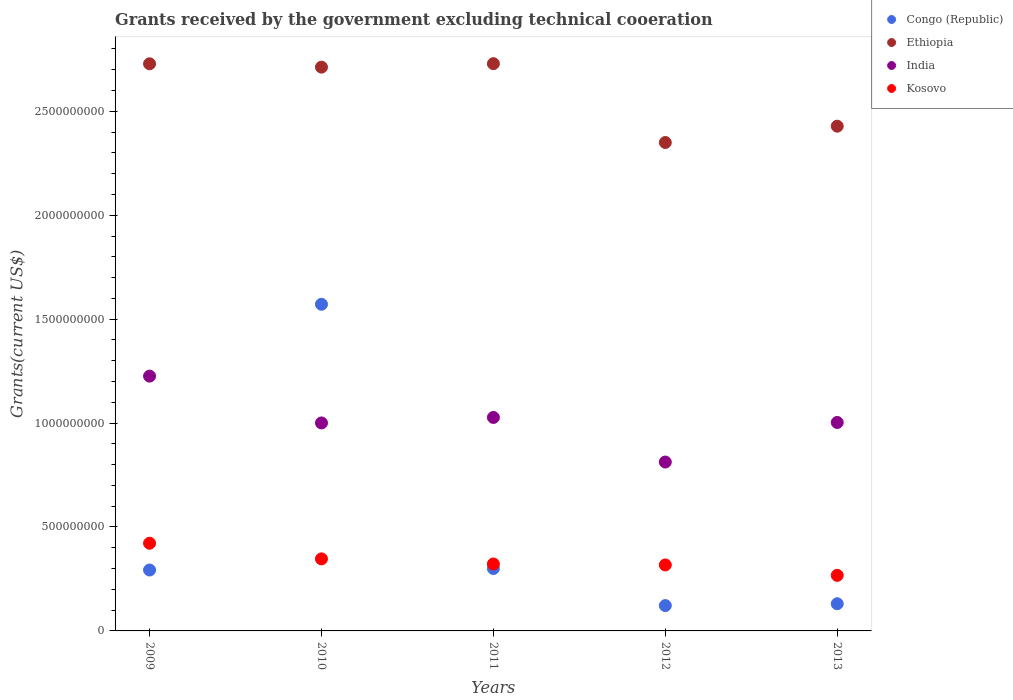Is the number of dotlines equal to the number of legend labels?
Offer a very short reply. Yes. What is the total grants received by the government in Congo (Republic) in 2010?
Ensure brevity in your answer.  1.57e+09. Across all years, what is the maximum total grants received by the government in India?
Your answer should be very brief. 1.23e+09. Across all years, what is the minimum total grants received by the government in Kosovo?
Offer a terse response. 2.67e+08. In which year was the total grants received by the government in Ethiopia maximum?
Give a very brief answer. 2011. In which year was the total grants received by the government in Congo (Republic) minimum?
Offer a very short reply. 2012. What is the total total grants received by the government in Ethiopia in the graph?
Offer a terse response. 1.29e+1. What is the difference between the total grants received by the government in Congo (Republic) in 2010 and that in 2013?
Provide a short and direct response. 1.44e+09. What is the difference between the total grants received by the government in India in 2012 and the total grants received by the government in Ethiopia in 2010?
Provide a succinct answer. -1.90e+09. What is the average total grants received by the government in Kosovo per year?
Offer a very short reply. 3.35e+08. In the year 2009, what is the difference between the total grants received by the government in Ethiopia and total grants received by the government in Kosovo?
Your answer should be very brief. 2.31e+09. What is the ratio of the total grants received by the government in Ethiopia in 2011 to that in 2012?
Offer a very short reply. 1.16. Is the total grants received by the government in Congo (Republic) in 2010 less than that in 2011?
Make the answer very short. No. What is the difference between the highest and the second highest total grants received by the government in Congo (Republic)?
Ensure brevity in your answer.  1.27e+09. What is the difference between the highest and the lowest total grants received by the government in India?
Keep it short and to the point. 4.13e+08. Is it the case that in every year, the sum of the total grants received by the government in India and total grants received by the government in Ethiopia  is greater than the total grants received by the government in Congo (Republic)?
Your answer should be compact. Yes. Does the total grants received by the government in Ethiopia monotonically increase over the years?
Provide a short and direct response. No. Is the total grants received by the government in Kosovo strictly greater than the total grants received by the government in Ethiopia over the years?
Offer a very short reply. No. Is the total grants received by the government in Kosovo strictly less than the total grants received by the government in India over the years?
Your answer should be compact. Yes. How many dotlines are there?
Provide a short and direct response. 4. How many years are there in the graph?
Your answer should be very brief. 5. Are the values on the major ticks of Y-axis written in scientific E-notation?
Make the answer very short. No. Does the graph contain any zero values?
Your response must be concise. No. Does the graph contain grids?
Provide a succinct answer. No. How many legend labels are there?
Offer a very short reply. 4. What is the title of the graph?
Give a very brief answer. Grants received by the government excluding technical cooeration. What is the label or title of the Y-axis?
Provide a succinct answer. Grants(current US$). What is the Grants(current US$) of Congo (Republic) in 2009?
Your answer should be very brief. 2.93e+08. What is the Grants(current US$) in Ethiopia in 2009?
Your response must be concise. 2.73e+09. What is the Grants(current US$) in India in 2009?
Make the answer very short. 1.23e+09. What is the Grants(current US$) in Kosovo in 2009?
Give a very brief answer. 4.22e+08. What is the Grants(current US$) in Congo (Republic) in 2010?
Ensure brevity in your answer.  1.57e+09. What is the Grants(current US$) in Ethiopia in 2010?
Offer a terse response. 2.71e+09. What is the Grants(current US$) in India in 2010?
Your response must be concise. 1.00e+09. What is the Grants(current US$) of Kosovo in 2010?
Provide a succinct answer. 3.47e+08. What is the Grants(current US$) of Congo (Republic) in 2011?
Your answer should be compact. 3.00e+08. What is the Grants(current US$) of Ethiopia in 2011?
Provide a succinct answer. 2.73e+09. What is the Grants(current US$) in India in 2011?
Offer a very short reply. 1.03e+09. What is the Grants(current US$) in Kosovo in 2011?
Provide a succinct answer. 3.22e+08. What is the Grants(current US$) in Congo (Republic) in 2012?
Make the answer very short. 1.22e+08. What is the Grants(current US$) of Ethiopia in 2012?
Give a very brief answer. 2.35e+09. What is the Grants(current US$) of India in 2012?
Give a very brief answer. 8.13e+08. What is the Grants(current US$) of Kosovo in 2012?
Provide a succinct answer. 3.17e+08. What is the Grants(current US$) in Congo (Republic) in 2013?
Make the answer very short. 1.31e+08. What is the Grants(current US$) in Ethiopia in 2013?
Offer a very short reply. 2.43e+09. What is the Grants(current US$) in India in 2013?
Your response must be concise. 1.00e+09. What is the Grants(current US$) of Kosovo in 2013?
Give a very brief answer. 2.67e+08. Across all years, what is the maximum Grants(current US$) in Congo (Republic)?
Your response must be concise. 1.57e+09. Across all years, what is the maximum Grants(current US$) in Ethiopia?
Make the answer very short. 2.73e+09. Across all years, what is the maximum Grants(current US$) of India?
Provide a short and direct response. 1.23e+09. Across all years, what is the maximum Grants(current US$) of Kosovo?
Your answer should be very brief. 4.22e+08. Across all years, what is the minimum Grants(current US$) in Congo (Republic)?
Your answer should be very brief. 1.22e+08. Across all years, what is the minimum Grants(current US$) of Ethiopia?
Keep it short and to the point. 2.35e+09. Across all years, what is the minimum Grants(current US$) in India?
Your answer should be compact. 8.13e+08. Across all years, what is the minimum Grants(current US$) in Kosovo?
Keep it short and to the point. 2.67e+08. What is the total Grants(current US$) in Congo (Republic) in the graph?
Keep it short and to the point. 2.42e+09. What is the total Grants(current US$) of Ethiopia in the graph?
Offer a terse response. 1.29e+1. What is the total Grants(current US$) in India in the graph?
Offer a terse response. 5.07e+09. What is the total Grants(current US$) in Kosovo in the graph?
Offer a terse response. 1.68e+09. What is the difference between the Grants(current US$) of Congo (Republic) in 2009 and that in 2010?
Your answer should be very brief. -1.28e+09. What is the difference between the Grants(current US$) in Ethiopia in 2009 and that in 2010?
Offer a terse response. 1.60e+07. What is the difference between the Grants(current US$) of India in 2009 and that in 2010?
Your answer should be compact. 2.25e+08. What is the difference between the Grants(current US$) in Kosovo in 2009 and that in 2010?
Offer a terse response. 7.53e+07. What is the difference between the Grants(current US$) of Congo (Republic) in 2009 and that in 2011?
Keep it short and to the point. -7.13e+06. What is the difference between the Grants(current US$) in Ethiopia in 2009 and that in 2011?
Your answer should be very brief. -6.20e+05. What is the difference between the Grants(current US$) of India in 2009 and that in 2011?
Ensure brevity in your answer.  1.99e+08. What is the difference between the Grants(current US$) in Kosovo in 2009 and that in 2011?
Your response must be concise. 9.97e+07. What is the difference between the Grants(current US$) in Congo (Republic) in 2009 and that in 2012?
Make the answer very short. 1.71e+08. What is the difference between the Grants(current US$) of Ethiopia in 2009 and that in 2012?
Make the answer very short. 3.79e+08. What is the difference between the Grants(current US$) of India in 2009 and that in 2012?
Offer a terse response. 4.13e+08. What is the difference between the Grants(current US$) of Kosovo in 2009 and that in 2012?
Keep it short and to the point. 1.04e+08. What is the difference between the Grants(current US$) in Congo (Republic) in 2009 and that in 2013?
Keep it short and to the point. 1.62e+08. What is the difference between the Grants(current US$) in Ethiopia in 2009 and that in 2013?
Give a very brief answer. 3.00e+08. What is the difference between the Grants(current US$) of India in 2009 and that in 2013?
Provide a short and direct response. 2.23e+08. What is the difference between the Grants(current US$) of Kosovo in 2009 and that in 2013?
Offer a very short reply. 1.55e+08. What is the difference between the Grants(current US$) in Congo (Republic) in 2010 and that in 2011?
Give a very brief answer. 1.27e+09. What is the difference between the Grants(current US$) in Ethiopia in 2010 and that in 2011?
Offer a terse response. -1.66e+07. What is the difference between the Grants(current US$) in India in 2010 and that in 2011?
Your response must be concise. -2.64e+07. What is the difference between the Grants(current US$) of Kosovo in 2010 and that in 2011?
Keep it short and to the point. 2.44e+07. What is the difference between the Grants(current US$) of Congo (Republic) in 2010 and that in 2012?
Your answer should be compact. 1.45e+09. What is the difference between the Grants(current US$) in Ethiopia in 2010 and that in 2012?
Your answer should be very brief. 3.63e+08. What is the difference between the Grants(current US$) in India in 2010 and that in 2012?
Offer a very short reply. 1.88e+08. What is the difference between the Grants(current US$) of Kosovo in 2010 and that in 2012?
Your answer should be very brief. 2.92e+07. What is the difference between the Grants(current US$) of Congo (Republic) in 2010 and that in 2013?
Ensure brevity in your answer.  1.44e+09. What is the difference between the Grants(current US$) of Ethiopia in 2010 and that in 2013?
Ensure brevity in your answer.  2.84e+08. What is the difference between the Grants(current US$) of India in 2010 and that in 2013?
Your answer should be compact. -2.22e+06. What is the difference between the Grants(current US$) in Kosovo in 2010 and that in 2013?
Provide a short and direct response. 7.93e+07. What is the difference between the Grants(current US$) in Congo (Republic) in 2011 and that in 2012?
Offer a very short reply. 1.78e+08. What is the difference between the Grants(current US$) of Ethiopia in 2011 and that in 2012?
Your answer should be very brief. 3.79e+08. What is the difference between the Grants(current US$) in India in 2011 and that in 2012?
Your answer should be very brief. 2.14e+08. What is the difference between the Grants(current US$) in Kosovo in 2011 and that in 2012?
Your response must be concise. 4.73e+06. What is the difference between the Grants(current US$) in Congo (Republic) in 2011 and that in 2013?
Keep it short and to the point. 1.69e+08. What is the difference between the Grants(current US$) of Ethiopia in 2011 and that in 2013?
Your answer should be compact. 3.01e+08. What is the difference between the Grants(current US$) in India in 2011 and that in 2013?
Your answer should be very brief. 2.42e+07. What is the difference between the Grants(current US$) of Kosovo in 2011 and that in 2013?
Make the answer very short. 5.48e+07. What is the difference between the Grants(current US$) in Congo (Republic) in 2012 and that in 2013?
Your answer should be very brief. -8.87e+06. What is the difference between the Grants(current US$) of Ethiopia in 2012 and that in 2013?
Give a very brief answer. -7.86e+07. What is the difference between the Grants(current US$) in India in 2012 and that in 2013?
Make the answer very short. -1.90e+08. What is the difference between the Grants(current US$) of Kosovo in 2012 and that in 2013?
Provide a short and direct response. 5.01e+07. What is the difference between the Grants(current US$) in Congo (Republic) in 2009 and the Grants(current US$) in Ethiopia in 2010?
Keep it short and to the point. -2.42e+09. What is the difference between the Grants(current US$) in Congo (Republic) in 2009 and the Grants(current US$) in India in 2010?
Your answer should be compact. -7.08e+08. What is the difference between the Grants(current US$) of Congo (Republic) in 2009 and the Grants(current US$) of Kosovo in 2010?
Provide a short and direct response. -5.36e+07. What is the difference between the Grants(current US$) in Ethiopia in 2009 and the Grants(current US$) in India in 2010?
Keep it short and to the point. 1.73e+09. What is the difference between the Grants(current US$) of Ethiopia in 2009 and the Grants(current US$) of Kosovo in 2010?
Provide a short and direct response. 2.38e+09. What is the difference between the Grants(current US$) of India in 2009 and the Grants(current US$) of Kosovo in 2010?
Your response must be concise. 8.79e+08. What is the difference between the Grants(current US$) in Congo (Republic) in 2009 and the Grants(current US$) in Ethiopia in 2011?
Make the answer very short. -2.44e+09. What is the difference between the Grants(current US$) of Congo (Republic) in 2009 and the Grants(current US$) of India in 2011?
Provide a short and direct response. -7.34e+08. What is the difference between the Grants(current US$) in Congo (Republic) in 2009 and the Grants(current US$) in Kosovo in 2011?
Make the answer very short. -2.91e+07. What is the difference between the Grants(current US$) of Ethiopia in 2009 and the Grants(current US$) of India in 2011?
Your answer should be very brief. 1.70e+09. What is the difference between the Grants(current US$) of Ethiopia in 2009 and the Grants(current US$) of Kosovo in 2011?
Give a very brief answer. 2.41e+09. What is the difference between the Grants(current US$) of India in 2009 and the Grants(current US$) of Kosovo in 2011?
Offer a terse response. 9.04e+08. What is the difference between the Grants(current US$) of Congo (Republic) in 2009 and the Grants(current US$) of Ethiopia in 2012?
Keep it short and to the point. -2.06e+09. What is the difference between the Grants(current US$) of Congo (Republic) in 2009 and the Grants(current US$) of India in 2012?
Your answer should be very brief. -5.20e+08. What is the difference between the Grants(current US$) of Congo (Republic) in 2009 and the Grants(current US$) of Kosovo in 2012?
Your answer should be compact. -2.44e+07. What is the difference between the Grants(current US$) in Ethiopia in 2009 and the Grants(current US$) in India in 2012?
Ensure brevity in your answer.  1.92e+09. What is the difference between the Grants(current US$) in Ethiopia in 2009 and the Grants(current US$) in Kosovo in 2012?
Provide a short and direct response. 2.41e+09. What is the difference between the Grants(current US$) in India in 2009 and the Grants(current US$) in Kosovo in 2012?
Your answer should be very brief. 9.08e+08. What is the difference between the Grants(current US$) in Congo (Republic) in 2009 and the Grants(current US$) in Ethiopia in 2013?
Your response must be concise. -2.14e+09. What is the difference between the Grants(current US$) of Congo (Republic) in 2009 and the Grants(current US$) of India in 2013?
Offer a very short reply. -7.10e+08. What is the difference between the Grants(current US$) in Congo (Republic) in 2009 and the Grants(current US$) in Kosovo in 2013?
Your answer should be very brief. 2.57e+07. What is the difference between the Grants(current US$) of Ethiopia in 2009 and the Grants(current US$) of India in 2013?
Ensure brevity in your answer.  1.73e+09. What is the difference between the Grants(current US$) in Ethiopia in 2009 and the Grants(current US$) in Kosovo in 2013?
Make the answer very short. 2.46e+09. What is the difference between the Grants(current US$) in India in 2009 and the Grants(current US$) in Kosovo in 2013?
Provide a short and direct response. 9.59e+08. What is the difference between the Grants(current US$) of Congo (Republic) in 2010 and the Grants(current US$) of Ethiopia in 2011?
Ensure brevity in your answer.  -1.16e+09. What is the difference between the Grants(current US$) of Congo (Republic) in 2010 and the Grants(current US$) of India in 2011?
Offer a terse response. 5.45e+08. What is the difference between the Grants(current US$) in Congo (Republic) in 2010 and the Grants(current US$) in Kosovo in 2011?
Provide a short and direct response. 1.25e+09. What is the difference between the Grants(current US$) in Ethiopia in 2010 and the Grants(current US$) in India in 2011?
Your answer should be compact. 1.69e+09. What is the difference between the Grants(current US$) in Ethiopia in 2010 and the Grants(current US$) in Kosovo in 2011?
Your answer should be very brief. 2.39e+09. What is the difference between the Grants(current US$) of India in 2010 and the Grants(current US$) of Kosovo in 2011?
Give a very brief answer. 6.78e+08. What is the difference between the Grants(current US$) in Congo (Republic) in 2010 and the Grants(current US$) in Ethiopia in 2012?
Give a very brief answer. -7.78e+08. What is the difference between the Grants(current US$) in Congo (Republic) in 2010 and the Grants(current US$) in India in 2012?
Keep it short and to the point. 7.59e+08. What is the difference between the Grants(current US$) in Congo (Republic) in 2010 and the Grants(current US$) in Kosovo in 2012?
Your answer should be compact. 1.25e+09. What is the difference between the Grants(current US$) of Ethiopia in 2010 and the Grants(current US$) of India in 2012?
Offer a very short reply. 1.90e+09. What is the difference between the Grants(current US$) in Ethiopia in 2010 and the Grants(current US$) in Kosovo in 2012?
Offer a very short reply. 2.40e+09. What is the difference between the Grants(current US$) of India in 2010 and the Grants(current US$) of Kosovo in 2012?
Give a very brief answer. 6.83e+08. What is the difference between the Grants(current US$) in Congo (Republic) in 2010 and the Grants(current US$) in Ethiopia in 2013?
Ensure brevity in your answer.  -8.57e+08. What is the difference between the Grants(current US$) in Congo (Republic) in 2010 and the Grants(current US$) in India in 2013?
Offer a terse response. 5.69e+08. What is the difference between the Grants(current US$) in Congo (Republic) in 2010 and the Grants(current US$) in Kosovo in 2013?
Keep it short and to the point. 1.30e+09. What is the difference between the Grants(current US$) of Ethiopia in 2010 and the Grants(current US$) of India in 2013?
Offer a terse response. 1.71e+09. What is the difference between the Grants(current US$) of Ethiopia in 2010 and the Grants(current US$) of Kosovo in 2013?
Your answer should be very brief. 2.45e+09. What is the difference between the Grants(current US$) of India in 2010 and the Grants(current US$) of Kosovo in 2013?
Offer a terse response. 7.33e+08. What is the difference between the Grants(current US$) of Congo (Republic) in 2011 and the Grants(current US$) of Ethiopia in 2012?
Your answer should be very brief. -2.05e+09. What is the difference between the Grants(current US$) of Congo (Republic) in 2011 and the Grants(current US$) of India in 2012?
Offer a very short reply. -5.12e+08. What is the difference between the Grants(current US$) in Congo (Republic) in 2011 and the Grants(current US$) in Kosovo in 2012?
Make the answer very short. -1.73e+07. What is the difference between the Grants(current US$) of Ethiopia in 2011 and the Grants(current US$) of India in 2012?
Make the answer very short. 1.92e+09. What is the difference between the Grants(current US$) in Ethiopia in 2011 and the Grants(current US$) in Kosovo in 2012?
Offer a terse response. 2.41e+09. What is the difference between the Grants(current US$) in India in 2011 and the Grants(current US$) in Kosovo in 2012?
Provide a succinct answer. 7.10e+08. What is the difference between the Grants(current US$) of Congo (Republic) in 2011 and the Grants(current US$) of Ethiopia in 2013?
Give a very brief answer. -2.13e+09. What is the difference between the Grants(current US$) in Congo (Republic) in 2011 and the Grants(current US$) in India in 2013?
Make the answer very short. -7.03e+08. What is the difference between the Grants(current US$) in Congo (Republic) in 2011 and the Grants(current US$) in Kosovo in 2013?
Your answer should be compact. 3.28e+07. What is the difference between the Grants(current US$) in Ethiopia in 2011 and the Grants(current US$) in India in 2013?
Ensure brevity in your answer.  1.73e+09. What is the difference between the Grants(current US$) in Ethiopia in 2011 and the Grants(current US$) in Kosovo in 2013?
Give a very brief answer. 2.46e+09. What is the difference between the Grants(current US$) in India in 2011 and the Grants(current US$) in Kosovo in 2013?
Your response must be concise. 7.60e+08. What is the difference between the Grants(current US$) in Congo (Republic) in 2012 and the Grants(current US$) in Ethiopia in 2013?
Your answer should be compact. -2.31e+09. What is the difference between the Grants(current US$) of Congo (Republic) in 2012 and the Grants(current US$) of India in 2013?
Provide a short and direct response. -8.81e+08. What is the difference between the Grants(current US$) in Congo (Republic) in 2012 and the Grants(current US$) in Kosovo in 2013?
Provide a short and direct response. -1.45e+08. What is the difference between the Grants(current US$) of Ethiopia in 2012 and the Grants(current US$) of India in 2013?
Ensure brevity in your answer.  1.35e+09. What is the difference between the Grants(current US$) in Ethiopia in 2012 and the Grants(current US$) in Kosovo in 2013?
Keep it short and to the point. 2.08e+09. What is the difference between the Grants(current US$) of India in 2012 and the Grants(current US$) of Kosovo in 2013?
Provide a short and direct response. 5.45e+08. What is the average Grants(current US$) of Congo (Republic) per year?
Offer a very short reply. 4.83e+08. What is the average Grants(current US$) of Ethiopia per year?
Provide a succinct answer. 2.59e+09. What is the average Grants(current US$) of India per year?
Give a very brief answer. 1.01e+09. What is the average Grants(current US$) in Kosovo per year?
Make the answer very short. 3.35e+08. In the year 2009, what is the difference between the Grants(current US$) in Congo (Republic) and Grants(current US$) in Ethiopia?
Your answer should be very brief. -2.44e+09. In the year 2009, what is the difference between the Grants(current US$) of Congo (Republic) and Grants(current US$) of India?
Keep it short and to the point. -9.33e+08. In the year 2009, what is the difference between the Grants(current US$) in Congo (Republic) and Grants(current US$) in Kosovo?
Offer a terse response. -1.29e+08. In the year 2009, what is the difference between the Grants(current US$) in Ethiopia and Grants(current US$) in India?
Make the answer very short. 1.50e+09. In the year 2009, what is the difference between the Grants(current US$) in Ethiopia and Grants(current US$) in Kosovo?
Offer a very short reply. 2.31e+09. In the year 2009, what is the difference between the Grants(current US$) of India and Grants(current US$) of Kosovo?
Make the answer very short. 8.04e+08. In the year 2010, what is the difference between the Grants(current US$) in Congo (Republic) and Grants(current US$) in Ethiopia?
Give a very brief answer. -1.14e+09. In the year 2010, what is the difference between the Grants(current US$) in Congo (Republic) and Grants(current US$) in India?
Offer a very short reply. 5.71e+08. In the year 2010, what is the difference between the Grants(current US$) of Congo (Republic) and Grants(current US$) of Kosovo?
Ensure brevity in your answer.  1.22e+09. In the year 2010, what is the difference between the Grants(current US$) in Ethiopia and Grants(current US$) in India?
Provide a short and direct response. 1.71e+09. In the year 2010, what is the difference between the Grants(current US$) of Ethiopia and Grants(current US$) of Kosovo?
Give a very brief answer. 2.37e+09. In the year 2010, what is the difference between the Grants(current US$) of India and Grants(current US$) of Kosovo?
Give a very brief answer. 6.54e+08. In the year 2011, what is the difference between the Grants(current US$) in Congo (Republic) and Grants(current US$) in Ethiopia?
Ensure brevity in your answer.  -2.43e+09. In the year 2011, what is the difference between the Grants(current US$) of Congo (Republic) and Grants(current US$) of India?
Give a very brief answer. -7.27e+08. In the year 2011, what is the difference between the Grants(current US$) in Congo (Republic) and Grants(current US$) in Kosovo?
Provide a succinct answer. -2.20e+07. In the year 2011, what is the difference between the Grants(current US$) in Ethiopia and Grants(current US$) in India?
Offer a terse response. 1.70e+09. In the year 2011, what is the difference between the Grants(current US$) in Ethiopia and Grants(current US$) in Kosovo?
Offer a very short reply. 2.41e+09. In the year 2011, what is the difference between the Grants(current US$) of India and Grants(current US$) of Kosovo?
Your answer should be very brief. 7.05e+08. In the year 2012, what is the difference between the Grants(current US$) in Congo (Republic) and Grants(current US$) in Ethiopia?
Give a very brief answer. -2.23e+09. In the year 2012, what is the difference between the Grants(current US$) of Congo (Republic) and Grants(current US$) of India?
Provide a succinct answer. -6.91e+08. In the year 2012, what is the difference between the Grants(current US$) in Congo (Republic) and Grants(current US$) in Kosovo?
Give a very brief answer. -1.96e+08. In the year 2012, what is the difference between the Grants(current US$) of Ethiopia and Grants(current US$) of India?
Your response must be concise. 1.54e+09. In the year 2012, what is the difference between the Grants(current US$) of Ethiopia and Grants(current US$) of Kosovo?
Your answer should be compact. 2.03e+09. In the year 2012, what is the difference between the Grants(current US$) in India and Grants(current US$) in Kosovo?
Offer a very short reply. 4.95e+08. In the year 2013, what is the difference between the Grants(current US$) in Congo (Republic) and Grants(current US$) in Ethiopia?
Your response must be concise. -2.30e+09. In the year 2013, what is the difference between the Grants(current US$) of Congo (Republic) and Grants(current US$) of India?
Make the answer very short. -8.72e+08. In the year 2013, what is the difference between the Grants(current US$) of Congo (Republic) and Grants(current US$) of Kosovo?
Ensure brevity in your answer.  -1.37e+08. In the year 2013, what is the difference between the Grants(current US$) in Ethiopia and Grants(current US$) in India?
Your answer should be very brief. 1.43e+09. In the year 2013, what is the difference between the Grants(current US$) of Ethiopia and Grants(current US$) of Kosovo?
Your answer should be compact. 2.16e+09. In the year 2013, what is the difference between the Grants(current US$) of India and Grants(current US$) of Kosovo?
Provide a short and direct response. 7.36e+08. What is the ratio of the Grants(current US$) in Congo (Republic) in 2009 to that in 2010?
Make the answer very short. 0.19. What is the ratio of the Grants(current US$) of Ethiopia in 2009 to that in 2010?
Keep it short and to the point. 1.01. What is the ratio of the Grants(current US$) in India in 2009 to that in 2010?
Give a very brief answer. 1.23. What is the ratio of the Grants(current US$) of Kosovo in 2009 to that in 2010?
Offer a very short reply. 1.22. What is the ratio of the Grants(current US$) in Congo (Republic) in 2009 to that in 2011?
Ensure brevity in your answer.  0.98. What is the ratio of the Grants(current US$) of India in 2009 to that in 2011?
Provide a succinct answer. 1.19. What is the ratio of the Grants(current US$) of Kosovo in 2009 to that in 2011?
Make the answer very short. 1.31. What is the ratio of the Grants(current US$) in Congo (Republic) in 2009 to that in 2012?
Offer a very short reply. 2.4. What is the ratio of the Grants(current US$) in Ethiopia in 2009 to that in 2012?
Offer a terse response. 1.16. What is the ratio of the Grants(current US$) of India in 2009 to that in 2012?
Keep it short and to the point. 1.51. What is the ratio of the Grants(current US$) of Kosovo in 2009 to that in 2012?
Provide a short and direct response. 1.33. What is the ratio of the Grants(current US$) in Congo (Republic) in 2009 to that in 2013?
Your response must be concise. 2.24. What is the ratio of the Grants(current US$) in Ethiopia in 2009 to that in 2013?
Ensure brevity in your answer.  1.12. What is the ratio of the Grants(current US$) of India in 2009 to that in 2013?
Provide a succinct answer. 1.22. What is the ratio of the Grants(current US$) of Kosovo in 2009 to that in 2013?
Your response must be concise. 1.58. What is the ratio of the Grants(current US$) of Congo (Republic) in 2010 to that in 2011?
Keep it short and to the point. 5.24. What is the ratio of the Grants(current US$) in Ethiopia in 2010 to that in 2011?
Make the answer very short. 0.99. What is the ratio of the Grants(current US$) of India in 2010 to that in 2011?
Keep it short and to the point. 0.97. What is the ratio of the Grants(current US$) of Kosovo in 2010 to that in 2011?
Provide a succinct answer. 1.08. What is the ratio of the Grants(current US$) in Congo (Republic) in 2010 to that in 2012?
Keep it short and to the point. 12.89. What is the ratio of the Grants(current US$) of Ethiopia in 2010 to that in 2012?
Make the answer very short. 1.15. What is the ratio of the Grants(current US$) of India in 2010 to that in 2012?
Ensure brevity in your answer.  1.23. What is the ratio of the Grants(current US$) of Kosovo in 2010 to that in 2012?
Keep it short and to the point. 1.09. What is the ratio of the Grants(current US$) in Congo (Republic) in 2010 to that in 2013?
Keep it short and to the point. 12.02. What is the ratio of the Grants(current US$) of Ethiopia in 2010 to that in 2013?
Your answer should be very brief. 1.12. What is the ratio of the Grants(current US$) of India in 2010 to that in 2013?
Your answer should be very brief. 1. What is the ratio of the Grants(current US$) in Kosovo in 2010 to that in 2013?
Keep it short and to the point. 1.3. What is the ratio of the Grants(current US$) of Congo (Republic) in 2011 to that in 2012?
Give a very brief answer. 2.46. What is the ratio of the Grants(current US$) in Ethiopia in 2011 to that in 2012?
Keep it short and to the point. 1.16. What is the ratio of the Grants(current US$) of India in 2011 to that in 2012?
Offer a terse response. 1.26. What is the ratio of the Grants(current US$) in Kosovo in 2011 to that in 2012?
Your response must be concise. 1.01. What is the ratio of the Grants(current US$) in Congo (Republic) in 2011 to that in 2013?
Provide a succinct answer. 2.3. What is the ratio of the Grants(current US$) in Ethiopia in 2011 to that in 2013?
Offer a terse response. 1.12. What is the ratio of the Grants(current US$) in India in 2011 to that in 2013?
Provide a succinct answer. 1.02. What is the ratio of the Grants(current US$) of Kosovo in 2011 to that in 2013?
Make the answer very short. 1.21. What is the ratio of the Grants(current US$) in Congo (Republic) in 2012 to that in 2013?
Your answer should be compact. 0.93. What is the ratio of the Grants(current US$) in Ethiopia in 2012 to that in 2013?
Keep it short and to the point. 0.97. What is the ratio of the Grants(current US$) in India in 2012 to that in 2013?
Give a very brief answer. 0.81. What is the ratio of the Grants(current US$) in Kosovo in 2012 to that in 2013?
Offer a very short reply. 1.19. What is the difference between the highest and the second highest Grants(current US$) in Congo (Republic)?
Keep it short and to the point. 1.27e+09. What is the difference between the highest and the second highest Grants(current US$) in Ethiopia?
Provide a succinct answer. 6.20e+05. What is the difference between the highest and the second highest Grants(current US$) in India?
Ensure brevity in your answer.  1.99e+08. What is the difference between the highest and the second highest Grants(current US$) of Kosovo?
Your answer should be very brief. 7.53e+07. What is the difference between the highest and the lowest Grants(current US$) of Congo (Republic)?
Your answer should be compact. 1.45e+09. What is the difference between the highest and the lowest Grants(current US$) of Ethiopia?
Your answer should be very brief. 3.79e+08. What is the difference between the highest and the lowest Grants(current US$) of India?
Make the answer very short. 4.13e+08. What is the difference between the highest and the lowest Grants(current US$) in Kosovo?
Provide a succinct answer. 1.55e+08. 